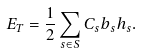Convert formula to latex. <formula><loc_0><loc_0><loc_500><loc_500>E _ { T } = \frac { 1 } { 2 } \sum _ { s \in S } C _ { s } b _ { s } h _ { s } .</formula> 